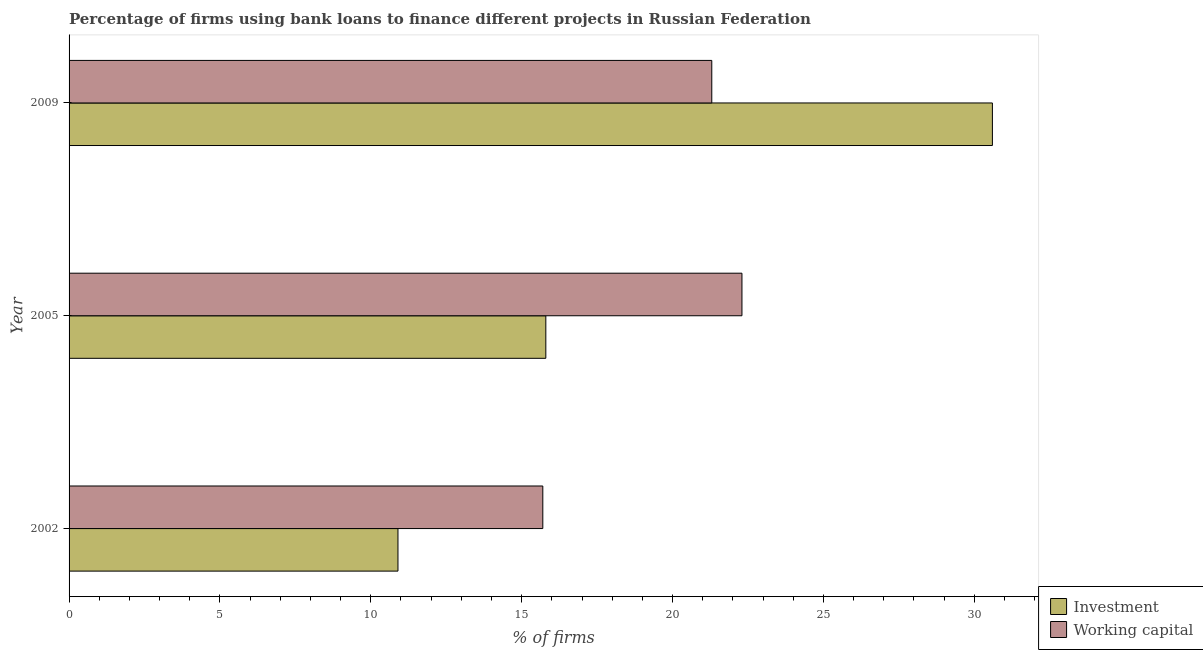In how many cases, is the number of bars for a given year not equal to the number of legend labels?
Offer a very short reply. 0. What is the percentage of firms using banks to finance working capital in 2002?
Give a very brief answer. 15.7. Across all years, what is the maximum percentage of firms using banks to finance investment?
Your answer should be compact. 30.6. Across all years, what is the minimum percentage of firms using banks to finance working capital?
Provide a short and direct response. 15.7. In which year was the percentage of firms using banks to finance working capital maximum?
Your response must be concise. 2005. In which year was the percentage of firms using banks to finance working capital minimum?
Offer a terse response. 2002. What is the total percentage of firms using banks to finance working capital in the graph?
Offer a terse response. 59.3. What is the difference between the percentage of firms using banks to finance working capital in 2002 and that in 2009?
Provide a short and direct response. -5.6. What is the difference between the percentage of firms using banks to finance working capital in 2009 and the percentage of firms using banks to finance investment in 2005?
Offer a very short reply. 5.5. What is the average percentage of firms using banks to finance investment per year?
Offer a terse response. 19.1. In the year 2005, what is the difference between the percentage of firms using banks to finance investment and percentage of firms using banks to finance working capital?
Offer a terse response. -6.5. In how many years, is the percentage of firms using banks to finance investment greater than 27 %?
Provide a succinct answer. 1. What is the ratio of the percentage of firms using banks to finance investment in 2002 to that in 2005?
Offer a terse response. 0.69. What is the difference between the highest and the second highest percentage of firms using banks to finance working capital?
Make the answer very short. 1. What is the difference between the highest and the lowest percentage of firms using banks to finance investment?
Offer a terse response. 19.7. Is the sum of the percentage of firms using banks to finance working capital in 2005 and 2009 greater than the maximum percentage of firms using banks to finance investment across all years?
Provide a short and direct response. Yes. What does the 2nd bar from the top in 2002 represents?
Ensure brevity in your answer.  Investment. What does the 2nd bar from the bottom in 2009 represents?
Ensure brevity in your answer.  Working capital. Are all the bars in the graph horizontal?
Make the answer very short. Yes. How many years are there in the graph?
Your response must be concise. 3. What is the difference between two consecutive major ticks on the X-axis?
Your answer should be very brief. 5. Where does the legend appear in the graph?
Your response must be concise. Bottom right. How many legend labels are there?
Provide a succinct answer. 2. What is the title of the graph?
Give a very brief answer. Percentage of firms using bank loans to finance different projects in Russian Federation. Does "Grants" appear as one of the legend labels in the graph?
Offer a terse response. No. What is the label or title of the X-axis?
Your response must be concise. % of firms. What is the label or title of the Y-axis?
Keep it short and to the point. Year. What is the % of firms of Working capital in 2005?
Give a very brief answer. 22.3. What is the % of firms in Investment in 2009?
Your answer should be compact. 30.6. What is the % of firms in Working capital in 2009?
Your response must be concise. 21.3. Across all years, what is the maximum % of firms in Investment?
Offer a very short reply. 30.6. Across all years, what is the maximum % of firms of Working capital?
Ensure brevity in your answer.  22.3. Across all years, what is the minimum % of firms in Investment?
Keep it short and to the point. 10.9. What is the total % of firms in Investment in the graph?
Keep it short and to the point. 57.3. What is the total % of firms in Working capital in the graph?
Give a very brief answer. 59.3. What is the difference between the % of firms of Working capital in 2002 and that in 2005?
Offer a very short reply. -6.6. What is the difference between the % of firms in Investment in 2002 and that in 2009?
Your response must be concise. -19.7. What is the difference between the % of firms in Investment in 2005 and that in 2009?
Your answer should be compact. -14.8. What is the difference between the % of firms of Working capital in 2005 and that in 2009?
Make the answer very short. 1. What is the difference between the % of firms in Investment in 2005 and the % of firms in Working capital in 2009?
Provide a short and direct response. -5.5. What is the average % of firms in Investment per year?
Your response must be concise. 19.1. What is the average % of firms of Working capital per year?
Your answer should be compact. 19.77. In the year 2002, what is the difference between the % of firms in Investment and % of firms in Working capital?
Provide a short and direct response. -4.8. What is the ratio of the % of firms in Investment in 2002 to that in 2005?
Your answer should be very brief. 0.69. What is the ratio of the % of firms of Working capital in 2002 to that in 2005?
Keep it short and to the point. 0.7. What is the ratio of the % of firms in Investment in 2002 to that in 2009?
Give a very brief answer. 0.36. What is the ratio of the % of firms in Working capital in 2002 to that in 2009?
Your answer should be compact. 0.74. What is the ratio of the % of firms in Investment in 2005 to that in 2009?
Offer a terse response. 0.52. What is the ratio of the % of firms of Working capital in 2005 to that in 2009?
Provide a short and direct response. 1.05. What is the difference between the highest and the second highest % of firms in Investment?
Keep it short and to the point. 14.8. What is the difference between the highest and the second highest % of firms in Working capital?
Provide a succinct answer. 1. What is the difference between the highest and the lowest % of firms in Investment?
Your answer should be very brief. 19.7. What is the difference between the highest and the lowest % of firms in Working capital?
Provide a short and direct response. 6.6. 